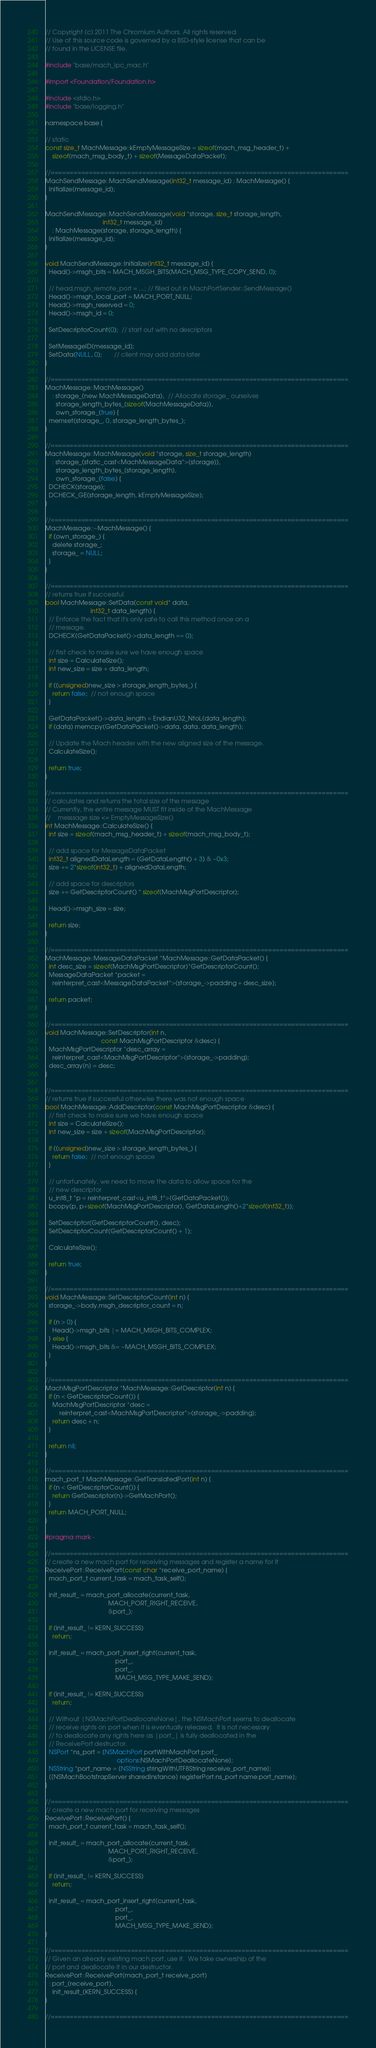<code> <loc_0><loc_0><loc_500><loc_500><_ObjectiveC_>// Copyright (c) 2011 The Chromium Authors. All rights reserved.
// Use of this source code is governed by a BSD-style license that can be
// found in the LICENSE file.

#include "base/mach_ipc_mac.h"

#import <Foundation/Foundation.h>

#include <stdio.h>
#include "base/logging.h"

namespace base {

// static
const size_t MachMessage::kEmptyMessageSize = sizeof(mach_msg_header_t) +
    sizeof(mach_msg_body_t) + sizeof(MessageDataPacket);

//==============================================================================
MachSendMessage::MachSendMessage(int32_t message_id) : MachMessage() {
  Initialize(message_id);
}

MachSendMessage::MachSendMessage(void *storage, size_t storage_length,
                                 int32_t message_id)
    : MachMessage(storage, storage_length) {
  Initialize(message_id);
}

void MachSendMessage::Initialize(int32_t message_id) {
  Head()->msgh_bits = MACH_MSGH_BITS(MACH_MSG_TYPE_COPY_SEND, 0);

  // head.msgh_remote_port = ...; // filled out in MachPortSender::SendMessage()
  Head()->msgh_local_port = MACH_PORT_NULL;
  Head()->msgh_reserved = 0;
  Head()->msgh_id = 0;

  SetDescriptorCount(0);  // start out with no descriptors

  SetMessageID(message_id);
  SetData(NULL, 0);       // client may add data later
}

//==============================================================================
MachMessage::MachMessage()
    : storage_(new MachMessageData),  // Allocate storage_ ourselves
      storage_length_bytes_(sizeof(MachMessageData)),
      own_storage_(true) {
  memset(storage_, 0, storage_length_bytes_);
}

//==============================================================================
MachMessage::MachMessage(void *storage, size_t storage_length)
    : storage_(static_cast<MachMessageData*>(storage)),
      storage_length_bytes_(storage_length),
      own_storage_(false) {
  DCHECK(storage);
  DCHECK_GE(storage_length, kEmptyMessageSize);
}

//==============================================================================
MachMessage::~MachMessage() {
  if (own_storage_) {
    delete storage_;
    storage_ = NULL;
  }
}

//==============================================================================
// returns true if successful
bool MachMessage::SetData(const void* data,
                          int32_t data_length) {
  // Enforce the fact that it's only safe to call this method once on a
  // message.
  DCHECK(GetDataPacket()->data_length == 0);

  // first check to make sure we have enough space
  int size = CalculateSize();
  int new_size = size + data_length;

  if ((unsigned)new_size > storage_length_bytes_) {
    return false;  // not enough space
  }

  GetDataPacket()->data_length = EndianU32_NtoL(data_length);
  if (data) memcpy(GetDataPacket()->data, data, data_length);

  // Update the Mach header with the new aligned size of the message.
  CalculateSize();

  return true;
}

//==============================================================================
// calculates and returns the total size of the message
// Currently, the entire message MUST fit inside of the MachMessage
//    messsage size <= EmptyMessageSize()
int MachMessage::CalculateSize() {
  int size = sizeof(mach_msg_header_t) + sizeof(mach_msg_body_t);

  // add space for MessageDataPacket
  int32_t alignedDataLength = (GetDataLength() + 3) & ~0x3;
  size += 2*sizeof(int32_t) + alignedDataLength;

  // add space for descriptors
  size += GetDescriptorCount() * sizeof(MachMsgPortDescriptor);

  Head()->msgh_size = size;

  return size;
}

//==============================================================================
MachMessage::MessageDataPacket *MachMessage::GetDataPacket() {
  int desc_size = sizeof(MachMsgPortDescriptor)*GetDescriptorCount();
  MessageDataPacket *packet =
    reinterpret_cast<MessageDataPacket*>(storage_->padding + desc_size);

  return packet;
}

//==============================================================================
void MachMessage::SetDescriptor(int n,
                                const MachMsgPortDescriptor &desc) {
  MachMsgPortDescriptor *desc_array =
    reinterpret_cast<MachMsgPortDescriptor*>(storage_->padding);
  desc_array[n] = desc;
}

//==============================================================================
// returns true if successful otherwise there was not enough space
bool MachMessage::AddDescriptor(const MachMsgPortDescriptor &desc) {
  // first check to make sure we have enough space
  int size = CalculateSize();
  int new_size = size + sizeof(MachMsgPortDescriptor);

  if ((unsigned)new_size > storage_length_bytes_) {
    return false;  // not enough space
  }

  // unfortunately, we need to move the data to allow space for the
  // new descriptor
  u_int8_t *p = reinterpret_cast<u_int8_t*>(GetDataPacket());
  bcopy(p, p+sizeof(MachMsgPortDescriptor), GetDataLength()+2*sizeof(int32_t));

  SetDescriptor(GetDescriptorCount(), desc);
  SetDescriptorCount(GetDescriptorCount() + 1);

  CalculateSize();

  return true;
}

//==============================================================================
void MachMessage::SetDescriptorCount(int n) {
  storage_->body.msgh_descriptor_count = n;

  if (n > 0) {
    Head()->msgh_bits |= MACH_MSGH_BITS_COMPLEX;
  } else {
    Head()->msgh_bits &= ~MACH_MSGH_BITS_COMPLEX;
  }
}

//==============================================================================
MachMsgPortDescriptor *MachMessage::GetDescriptor(int n) {
  if (n < GetDescriptorCount()) {
    MachMsgPortDescriptor *desc =
        reinterpret_cast<MachMsgPortDescriptor*>(storage_->padding);
    return desc + n;
  }

  return nil;
}

//==============================================================================
mach_port_t MachMessage::GetTranslatedPort(int n) {
  if (n < GetDescriptorCount()) {
    return GetDescriptor(n)->GetMachPort();
  }
  return MACH_PORT_NULL;
}

#pragma mark -

//==============================================================================
// create a new mach port for receiving messages and register a name for it
ReceivePort::ReceivePort(const char *receive_port_name) {
  mach_port_t current_task = mach_task_self();

  init_result_ = mach_port_allocate(current_task,
                                    MACH_PORT_RIGHT_RECEIVE,
                                    &port_);

  if (init_result_ != KERN_SUCCESS)
    return;

  init_result_ = mach_port_insert_right(current_task,
                                        port_,
                                        port_,
                                        MACH_MSG_TYPE_MAKE_SEND);

  if (init_result_ != KERN_SUCCESS)
    return;

  // Without |NSMachPortDeallocateNone|, the NSMachPort seems to deallocate
  // receive rights on port when it is eventually released.  It is not necessary
  // to deallocate any rights here as |port_| is fully deallocated in the
  // ReceivePort destructor.
  NSPort *ns_port = [NSMachPort portWithMachPort:port_
                                         options:NSMachPortDeallocateNone];
  NSString *port_name = [NSString stringWithUTF8String:receive_port_name];
  [[NSMachBootstrapServer sharedInstance] registerPort:ns_port name:port_name];
}

//==============================================================================
// create a new mach port for receiving messages
ReceivePort::ReceivePort() {
  mach_port_t current_task = mach_task_self();

  init_result_ = mach_port_allocate(current_task,
                                    MACH_PORT_RIGHT_RECEIVE,
                                    &port_);

  if (init_result_ != KERN_SUCCESS)
    return;

  init_result_ = mach_port_insert_right(current_task,
                                        port_,
                                        port_,
                                        MACH_MSG_TYPE_MAKE_SEND);
}

//==============================================================================
// Given an already existing mach port, use it.  We take ownership of the
// port and deallocate it in our destructor.
ReceivePort::ReceivePort(mach_port_t receive_port)
  : port_(receive_port),
    init_result_(KERN_SUCCESS) {
}

//==============================================================================</code> 